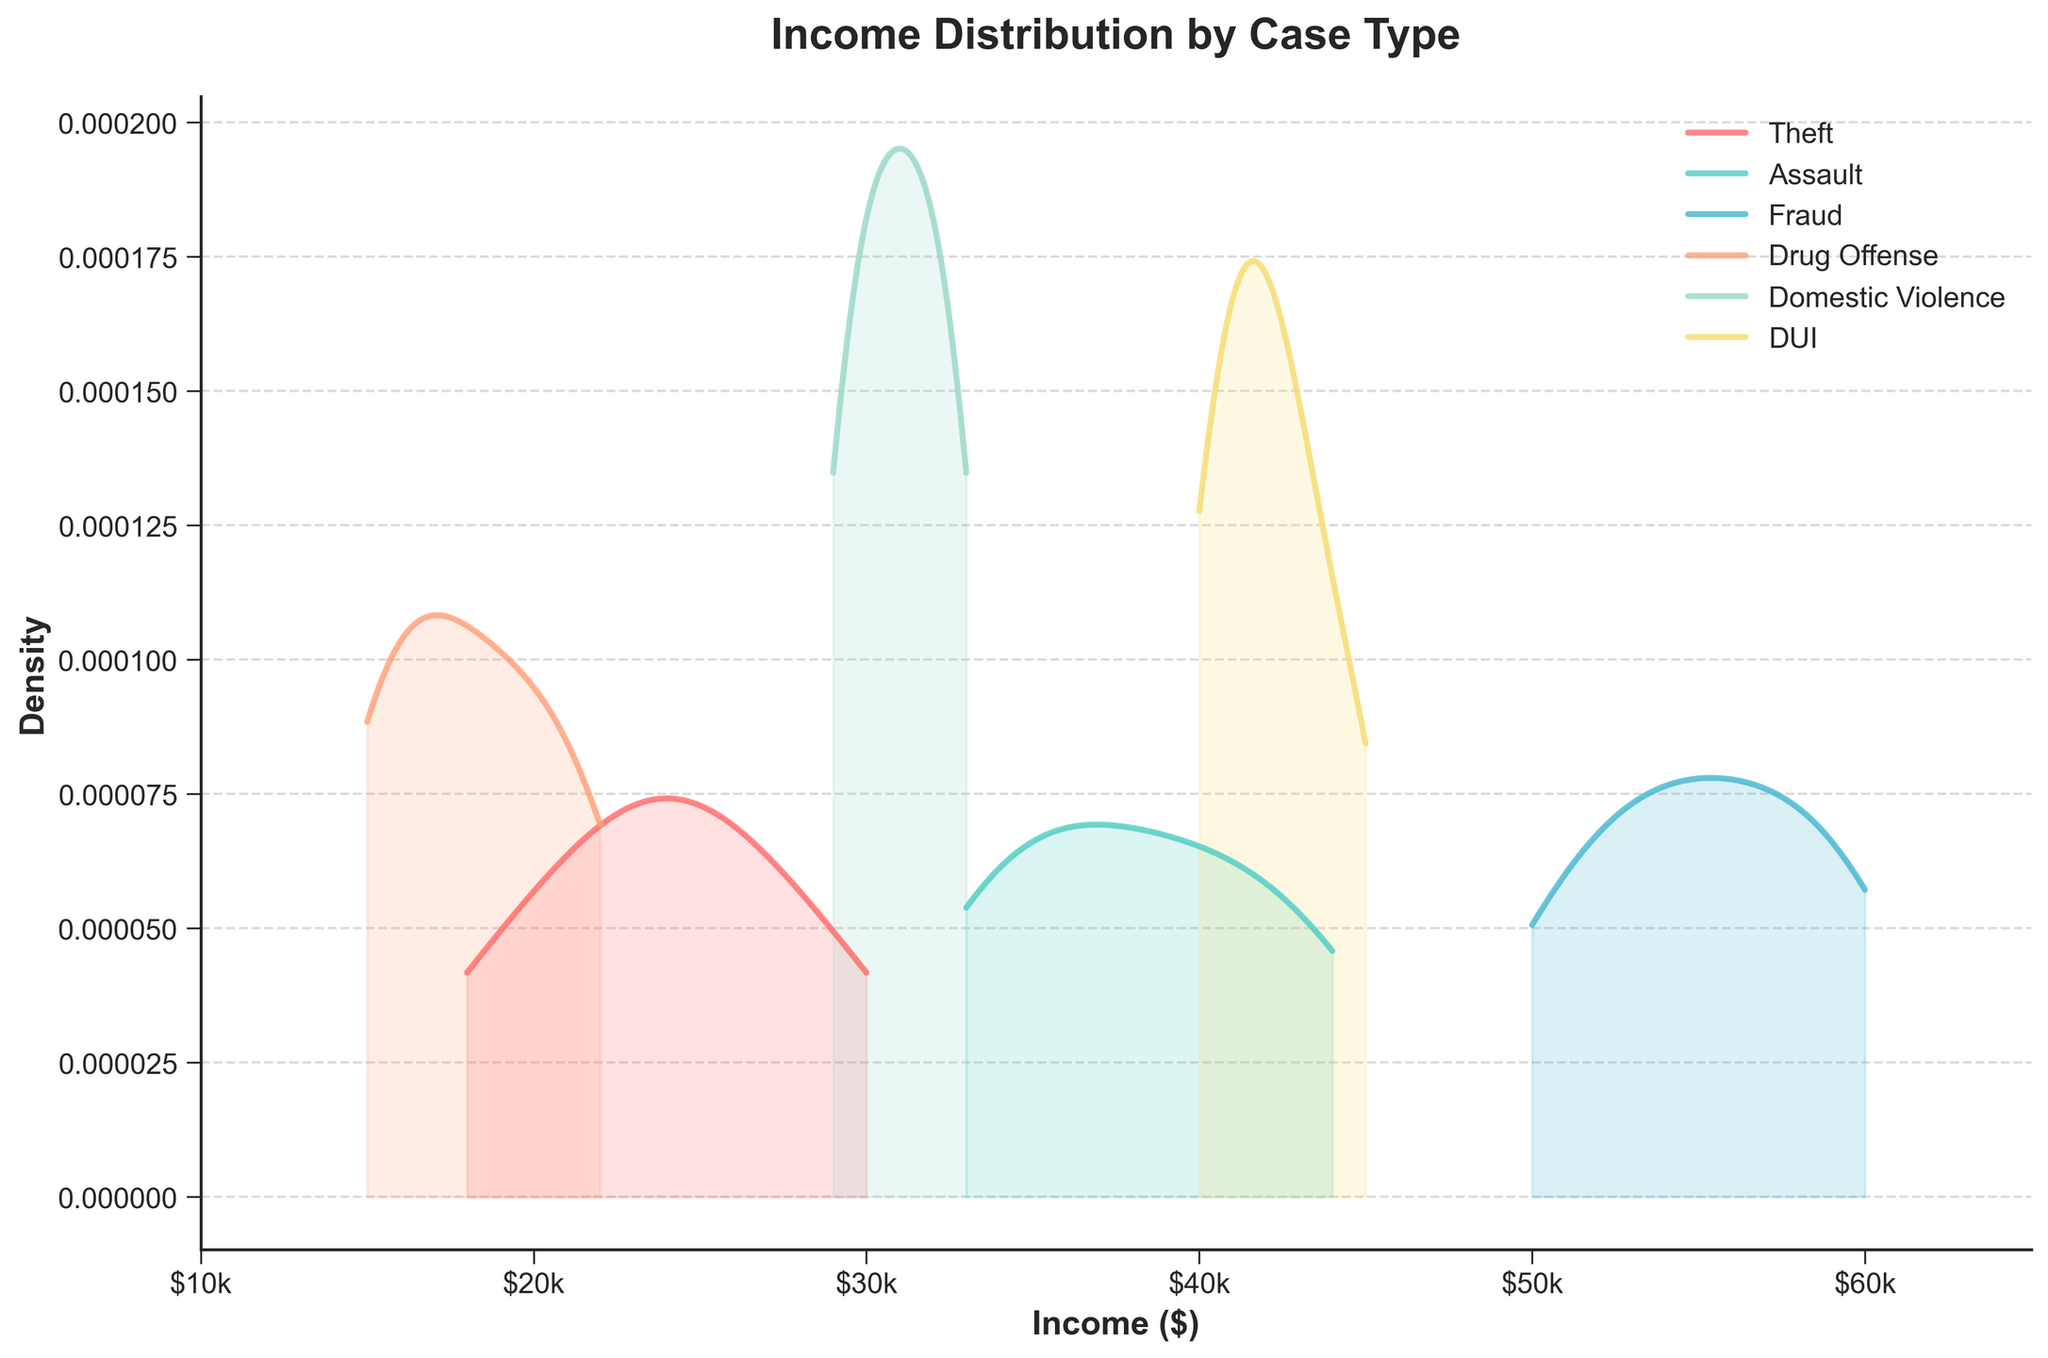What is the title of the plot? The title of the plot is located at the top of the figure and is usually the largest text. It reads "Income Distribution by Case Type" in bold.
Answer: Income Distribution by Case Type Which case type has the highest peak on the density plot? By examining the peaks of each density curve, the case type with the highest peak is "Fraud." The "Fraud" curve reaches the highest density.
Answer: Fraud What is the approximate income range for families involved in domestic violence cases? By looking at the density plot for "Domestic Violence," we can see where the curve starts and ends. The range is from roughly $29,000 to $33,000.
Answer: $29,000 to $33,000 How do the income distributions for theft and drug offences compare? Comparing the curves for "Theft" and "Drug Offense," "Drug Offense" has lower average incomes, about $15,000 to $22,000, whereas "Theft" has incomes ranging from $18,000 to $30,000.
Answer: Drug Offense lower than Theft Which case type has the widest income distribution? The width of the density distribution can be determined by the spread of the curve. "Fraud" has the widest spread, ranging from $50,000 to $60,000.
Answer: Fraud Which case type has the narrowest income distribution? The narrowest distribution curve can be determined by the smallest spread. "Domestic Violence" has the narrowest spread, ranging from $29,000 to $33,000.
Answer: Domestic Violence Is there a case type with incomes higher than $60,000? By observing the curves, no case types extend beyond $60,000. The highest value is from "Fraud" and it peaks around $60,000 but does not go higher.
Answer: No What is the income range for DUI cases? By observing the density plot for "DUI," we can see that the incomes range from $40,000 to $45,000.
Answer: $40,000 to $45,000 Are there more case types with lower incomes or higher incomes? By comparing the density plots, more case types (Theft, Assault, Drug Offense, Domestic Violence) have their densities skewed towards lower income ranges compared to higher income, which is mainly occupied by Fraud and DUI.
Answer: Lower incomes 